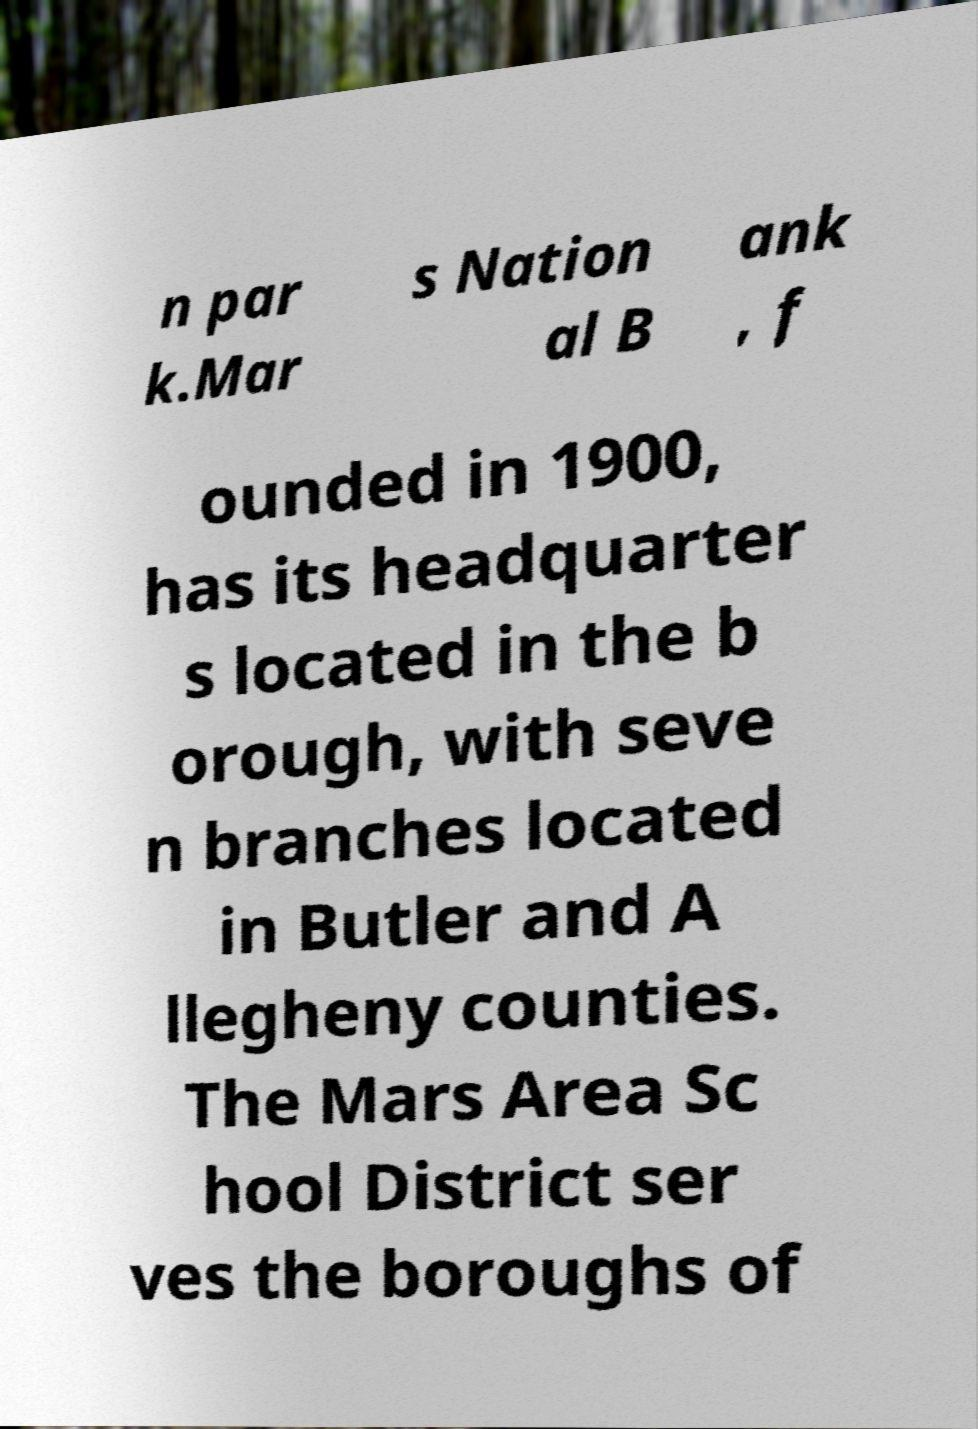Can you read and provide the text displayed in the image?This photo seems to have some interesting text. Can you extract and type it out for me? n par k.Mar s Nation al B ank , f ounded in 1900, has its headquarter s located in the b orough, with seve n branches located in Butler and A llegheny counties. The Mars Area Sc hool District ser ves the boroughs of 